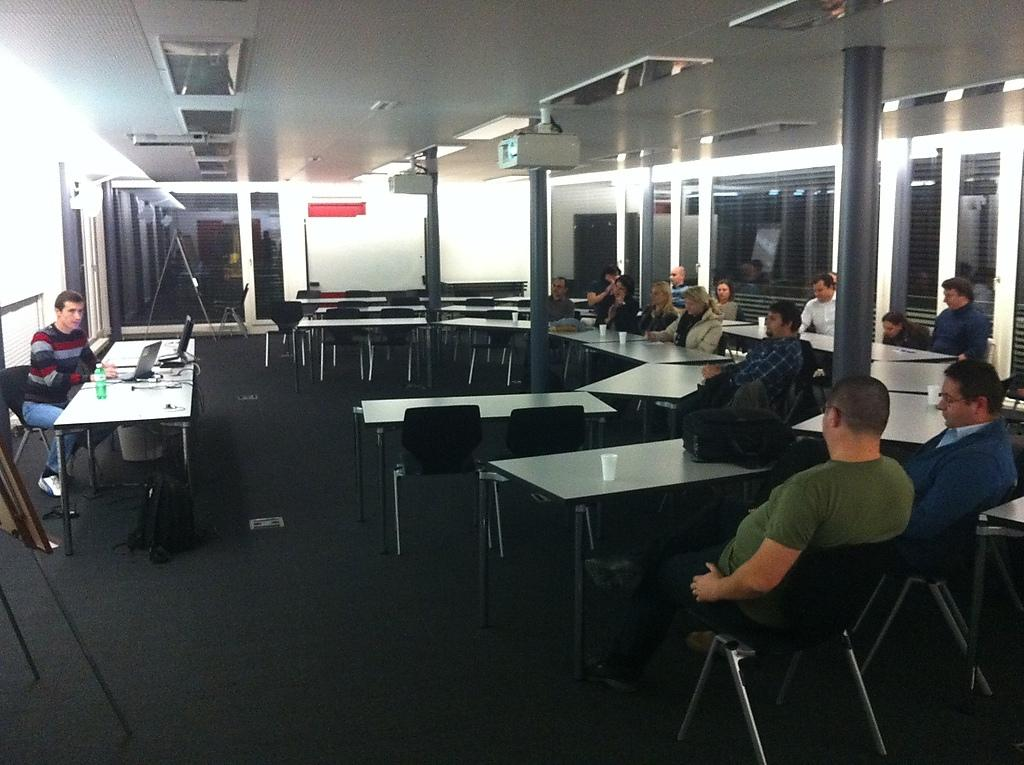How many people are in the image? There is a group of persons in the image. What are the persons doing in the image? The persons are sitting on chairs. Where is the scene taking place? The setting is in a room. What type of yarn is being used in the argument in the image? There is no argument or yarn present in the image. The persons are simply sitting on chairs in a room. 